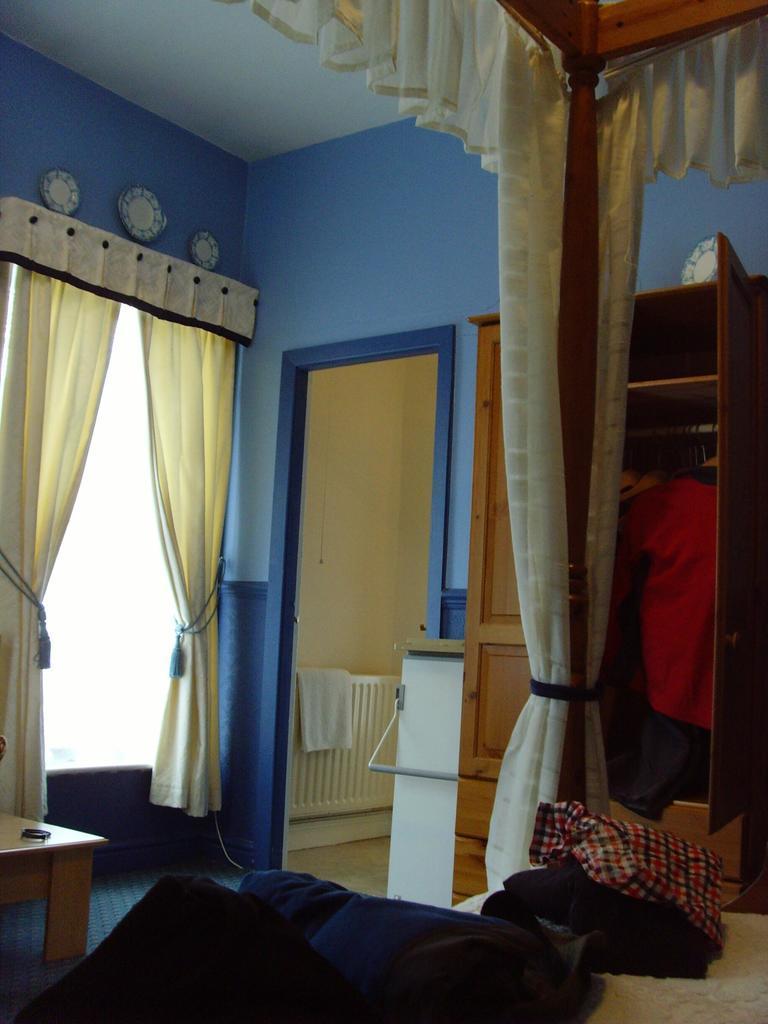In one or two sentences, can you explain what this image depicts? In this image we can see bed. On the bed there are clothes. Also there is a wooden pole with curtain. In the back there is a shelf. Near to the shelf there is a person. Also there is door. And we can see window with curtains. And there is a table. And through the door we can see railing with a cloth. 